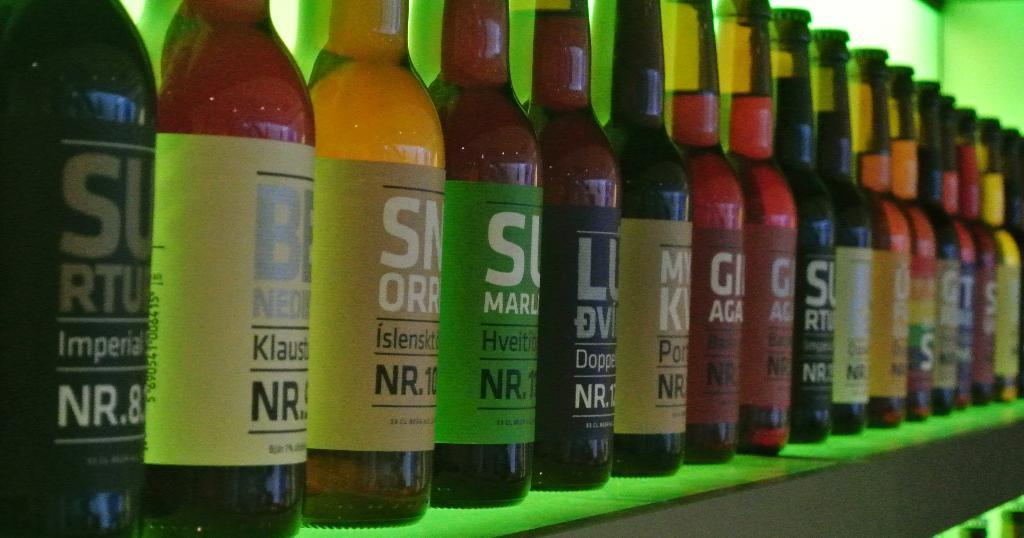Provide a one-sentence caption for the provided image. A row of bottles of drinks, all with the letters NR on each one. 